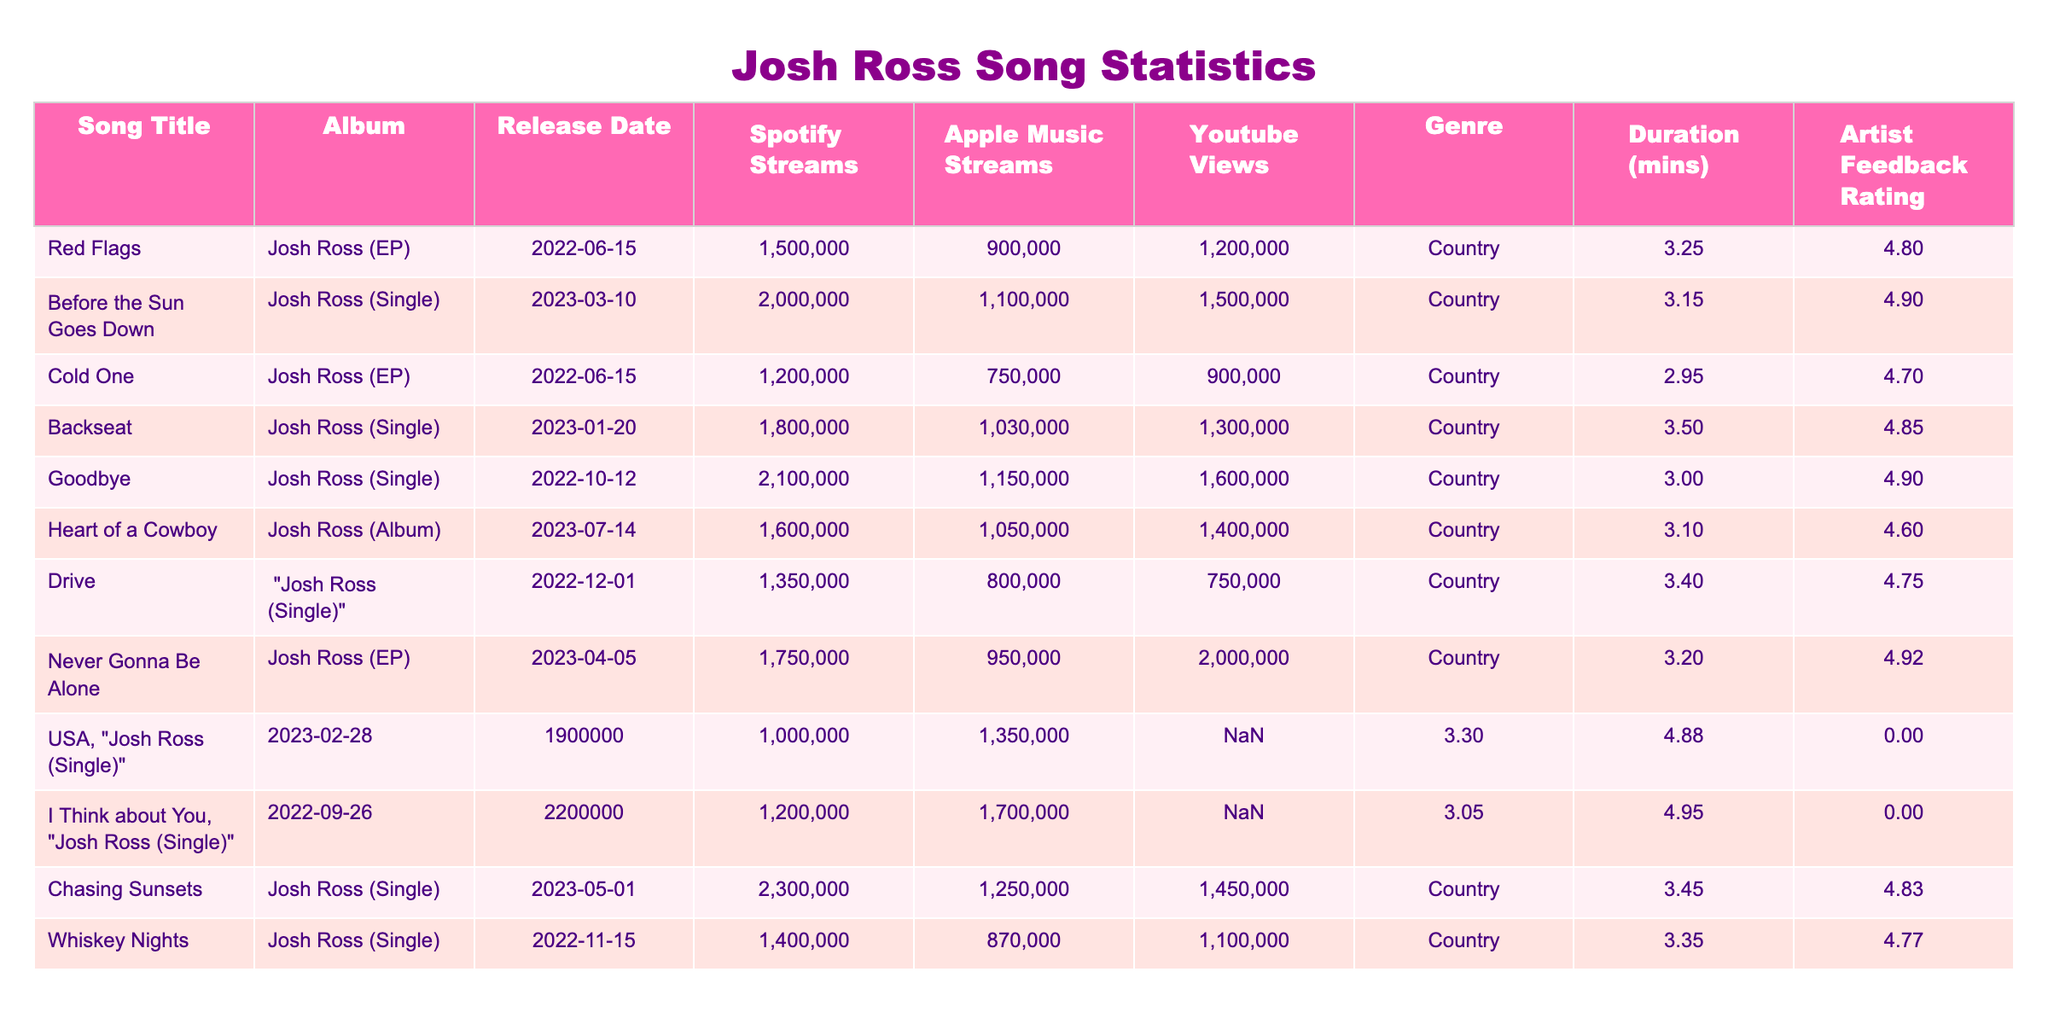What is the total number of Spotify streams for all songs? To get the total Spotify streams, we sum the Spotify streams of each song: 1500000 + 2000000 + 1200000 + 1800000 + 2100000 + 1600000 + 1350000 + 1750000 + 1900000 + 2200000 + 2300000 + 1400000 = 20500000
Answer: 20500000 Which song has the highest feedback rating? Looking through the artist feedback ratings in the table, "I Think about You" has the highest rating of 4.95
Answer: I Think about You How many songs were released in 2023? The songs released in 2023 are: "Before the Sun Goes Down," "Backseat," "Goodbye," "Heart of a Cowboy," "Never Gonna Be Alone," "USA," "Chasing Sunsets." There are 7 songs total
Answer: 7 What is the average duration of the songs? To find the average duration, we sum the durations: 3.25 + 3.15 + 2.95 + 3.50 + 3.00 + 3.10 + 3.40 + 3.20 + 3.30 + 3.05 + 3.45 + 3.35 = 38.75 minutes. There are 12 songs, so the average is 38.75 / 12 = 3.229 minutes
Answer: 3.23 Which song had more YouTube views than Spotify streams? Comparing the YouTube views and Spotify streams, "Drive" (YouTube: 750000 < Spotify: 1350000), "Cold One" (YouTube: 900000 < Spotify: 1200000), and "Whiskey Nights" (YouTube: 1100000 < Spotify: 1400000) have fewer views than streams. "Never Gonna Be Alone," (YouTube: 2000000 > Spotify: 1750000) and "I Think about You" (YouTube: 1700000 > Spotify: 2200000) have more views
Answer: Never Gonna Be Alone, I Think about You What is the total number of Apple Music streams for songs released in 2022? Focusing only on the songs from 2022: "Red Flags" (900000), "Cold One" (750000), "Drive" (800000), and "Whiskey Nights" (870000). The sum of these streams is: 900000 + 750000 + 800000 + 870000 = 3320000
Answer: 3320000 Which song had the highest number of YouTube views? Looking at the YouTube views, "Before the Sun Goes Down" has the highest at 1500000
Answer: Before the Sun Goes Down How many songs fall under the genre "Country"? All songs in the table are categorized as "Country." There are 12 songs in total
Answer: 12 What is the difference in Spotify streams between "Goodbye" and "Never Gonna Be Alone"? The Spotify streams for "Goodbye" are 2100000, and for "Never Gonna Be Alone," they are 1750000. The difference is 2100000 - 1750000 = 350000
Answer: 350000 Which song released last had fewer Spotify streams than "Cold One"? The last released song in the table is "Chasing Sunsets," which has 2300000 Spotify streams. "Cold One" has 1200000 streams. Comparing them, "Cold One" has fewer streams
Answer: Cold One 